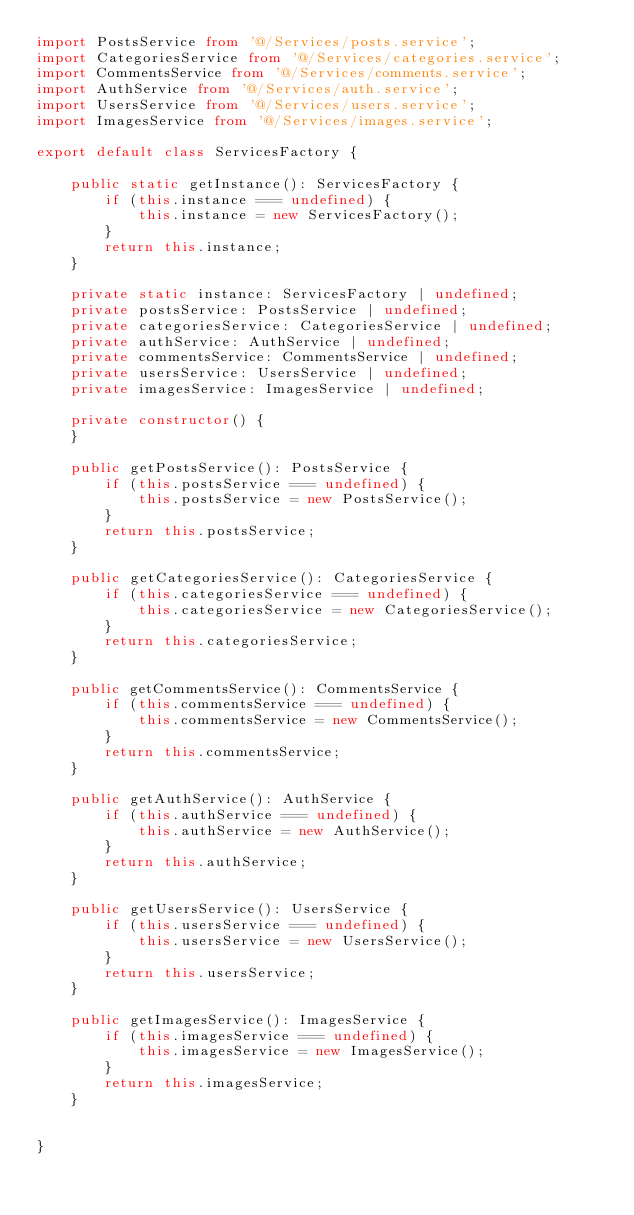<code> <loc_0><loc_0><loc_500><loc_500><_TypeScript_>import PostsService from '@/Services/posts.service';
import CategoriesService from '@/Services/categories.service';
import CommentsService from '@/Services/comments.service';
import AuthService from '@/Services/auth.service';
import UsersService from '@/Services/users.service';
import ImagesService from '@/Services/images.service';

export default class ServicesFactory {

    public static getInstance(): ServicesFactory {
        if (this.instance === undefined) {
            this.instance = new ServicesFactory();
        }
        return this.instance;
    }

    private static instance: ServicesFactory | undefined;
    private postsService: PostsService | undefined;
    private categoriesService: CategoriesService | undefined;
    private authService: AuthService | undefined;
    private commentsService: CommentsService | undefined;
    private usersService: UsersService | undefined;
    private imagesService: ImagesService | undefined;

    private constructor() {
    }

    public getPostsService(): PostsService {
        if (this.postsService === undefined) {
            this.postsService = new PostsService();
        }
        return this.postsService;
    }

    public getCategoriesService(): CategoriesService {
        if (this.categoriesService === undefined) {
            this.categoriesService = new CategoriesService();
        }
        return this.categoriesService;
    }

    public getCommentsService(): CommentsService {
        if (this.commentsService === undefined) {
            this.commentsService = new CommentsService();
        }
        return this.commentsService;
    }

    public getAuthService(): AuthService {
        if (this.authService === undefined) {
            this.authService = new AuthService();
        }
        return this.authService;
    }

    public getUsersService(): UsersService {
        if (this.usersService === undefined) {
            this.usersService = new UsersService();
        }
        return this.usersService;
    }

    public getImagesService(): ImagesService {
        if (this.imagesService === undefined) {
            this.imagesService = new ImagesService();
        }
        return this.imagesService;
    }


}
</code> 